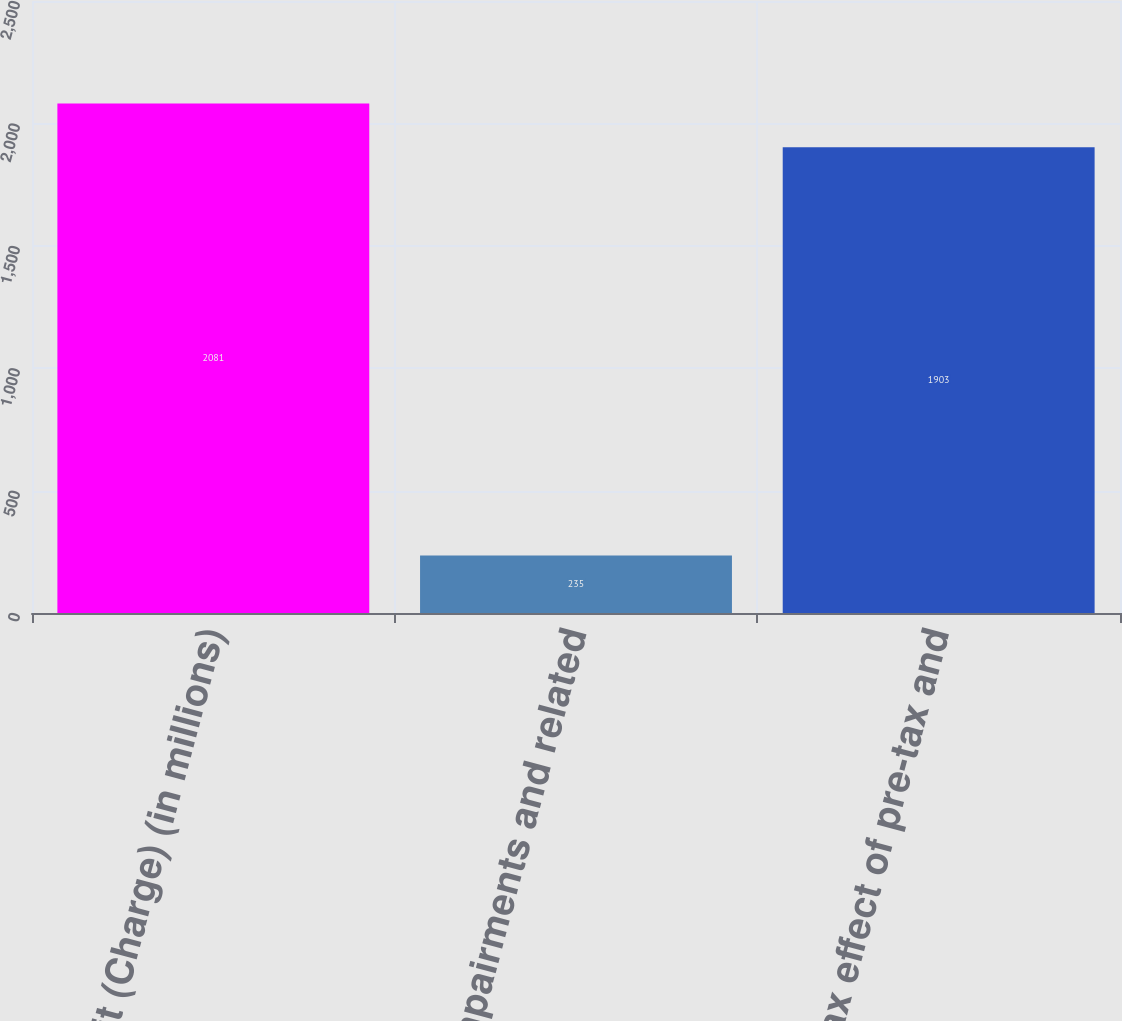Convert chart to OTSL. <chart><loc_0><loc_0><loc_500><loc_500><bar_chart><fcel>Benefit (Charge) (in millions)<fcel>Asset impairments and related<fcel>Tax effect of pre-tax and<nl><fcel>2081<fcel>235<fcel>1903<nl></chart> 